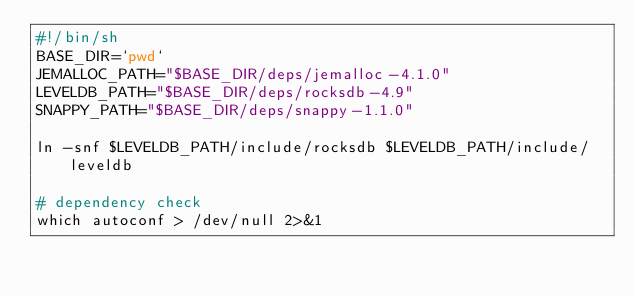<code> <loc_0><loc_0><loc_500><loc_500><_Bash_>#!/bin/sh
BASE_DIR=`pwd`
JEMALLOC_PATH="$BASE_DIR/deps/jemalloc-4.1.0"
LEVELDB_PATH="$BASE_DIR/deps/rocksdb-4.9"
SNAPPY_PATH="$BASE_DIR/deps/snappy-1.1.0"

ln -snf $LEVELDB_PATH/include/rocksdb $LEVELDB_PATH/include/leveldb

# dependency check
which autoconf > /dev/null 2>&1</code> 